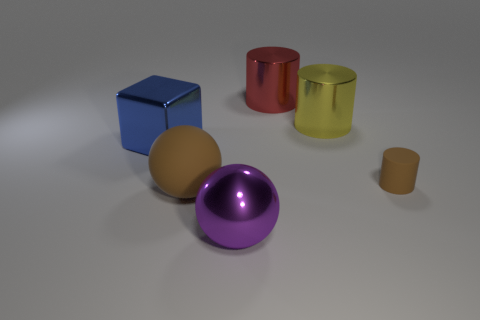Are there any objects that stand out due to their unique texture or finish? Certainly, the matte texture of the yellow ball differentiates it from the shiny surfaces of the other objects. This matte finish makes the yellow ball stand out despite its common spherical shape. 